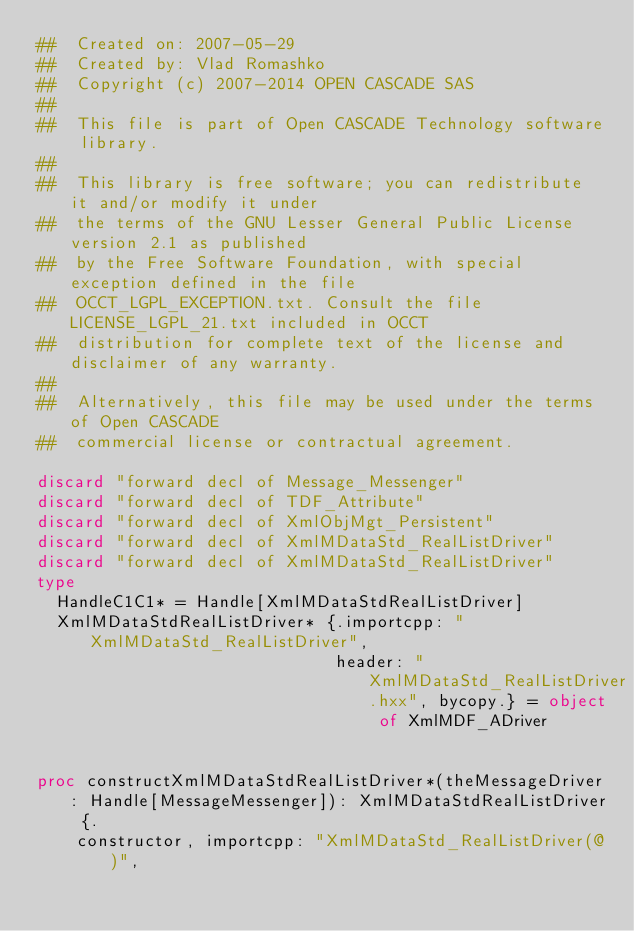<code> <loc_0><loc_0><loc_500><loc_500><_Nim_>##  Created on: 2007-05-29
##  Created by: Vlad Romashko
##  Copyright (c) 2007-2014 OPEN CASCADE SAS
##
##  This file is part of Open CASCADE Technology software library.
##
##  This library is free software; you can redistribute it and/or modify it under
##  the terms of the GNU Lesser General Public License version 2.1 as published
##  by the Free Software Foundation, with special exception defined in the file
##  OCCT_LGPL_EXCEPTION.txt. Consult the file LICENSE_LGPL_21.txt included in OCCT
##  distribution for complete text of the license and disclaimer of any warranty.
##
##  Alternatively, this file may be used under the terms of Open CASCADE
##  commercial license or contractual agreement.

discard "forward decl of Message_Messenger"
discard "forward decl of TDF_Attribute"
discard "forward decl of XmlObjMgt_Persistent"
discard "forward decl of XmlMDataStd_RealListDriver"
discard "forward decl of XmlMDataStd_RealListDriver"
type
  HandleC1C1* = Handle[XmlMDataStdRealListDriver]
  XmlMDataStdRealListDriver* {.importcpp: "XmlMDataStd_RealListDriver",
                              header: "XmlMDataStd_RealListDriver.hxx", bycopy.} = object of XmlMDF_ADriver


proc constructXmlMDataStdRealListDriver*(theMessageDriver: Handle[MessageMessenger]): XmlMDataStdRealListDriver {.
    constructor, importcpp: "XmlMDataStd_RealListDriver(@)",</code> 